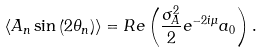Convert formula to latex. <formula><loc_0><loc_0><loc_500><loc_500>\langle A _ { n } \sin \left ( 2 \theta _ { n } \right ) \rangle = R e \left ( \frac { \sigma _ { A } ^ { 2 } } { 2 } e ^ { - 2 i \mu } a _ { 0 } \right ) .</formula> 